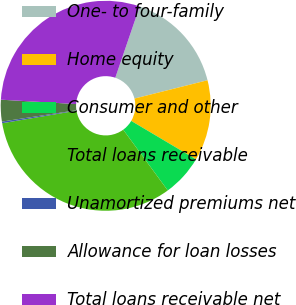Convert chart to OTSL. <chart><loc_0><loc_0><loc_500><loc_500><pie_chart><fcel>One- to four-family<fcel>Home equity<fcel>Consumer and other<fcel>Total loans receivable<fcel>Unamortized premiums net<fcel>Allowance for loan losses<fcel>Total loans receivable net<nl><fcel>15.84%<fcel>12.43%<fcel>6.41%<fcel>32.41%<fcel>0.25%<fcel>3.33%<fcel>29.32%<nl></chart> 